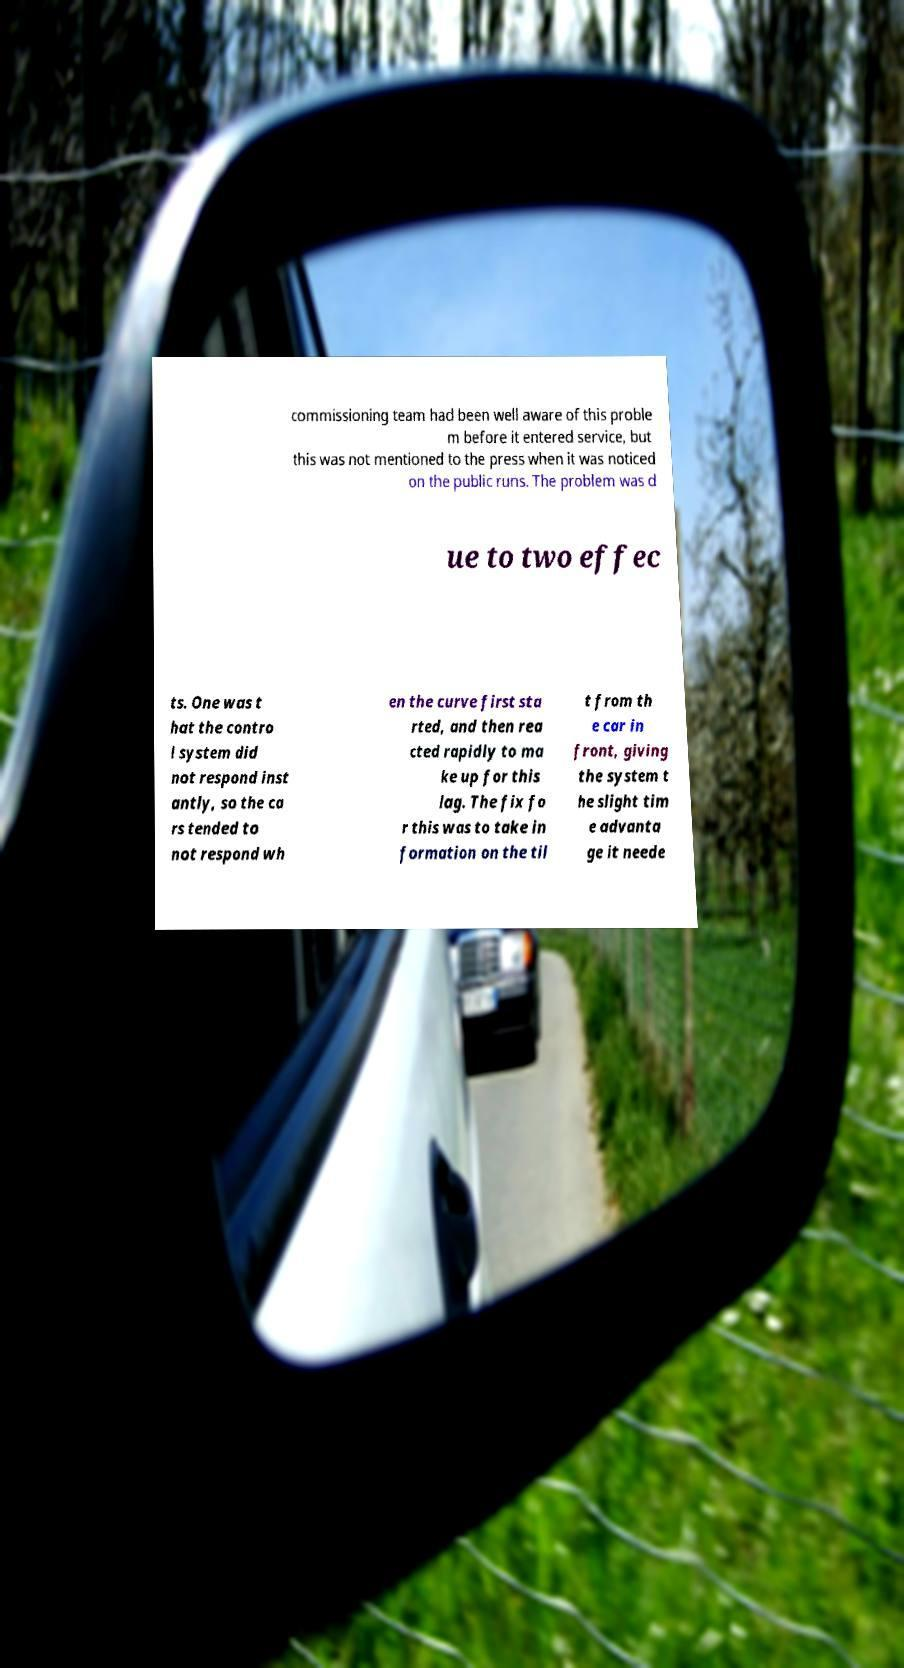Could you assist in decoding the text presented in this image and type it out clearly? commissioning team had been well aware of this proble m before it entered service, but this was not mentioned to the press when it was noticed on the public runs. The problem was d ue to two effec ts. One was t hat the contro l system did not respond inst antly, so the ca rs tended to not respond wh en the curve first sta rted, and then rea cted rapidly to ma ke up for this lag. The fix fo r this was to take in formation on the til t from th e car in front, giving the system t he slight tim e advanta ge it neede 